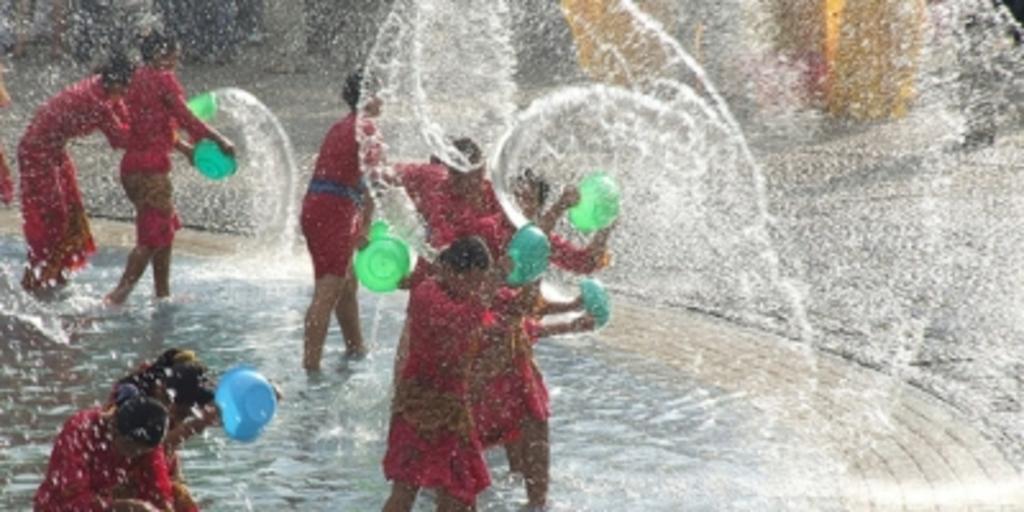Describe this image in one or two sentences. In this image, I can see few people standing and holding the bowls in their hands. These are the water. 